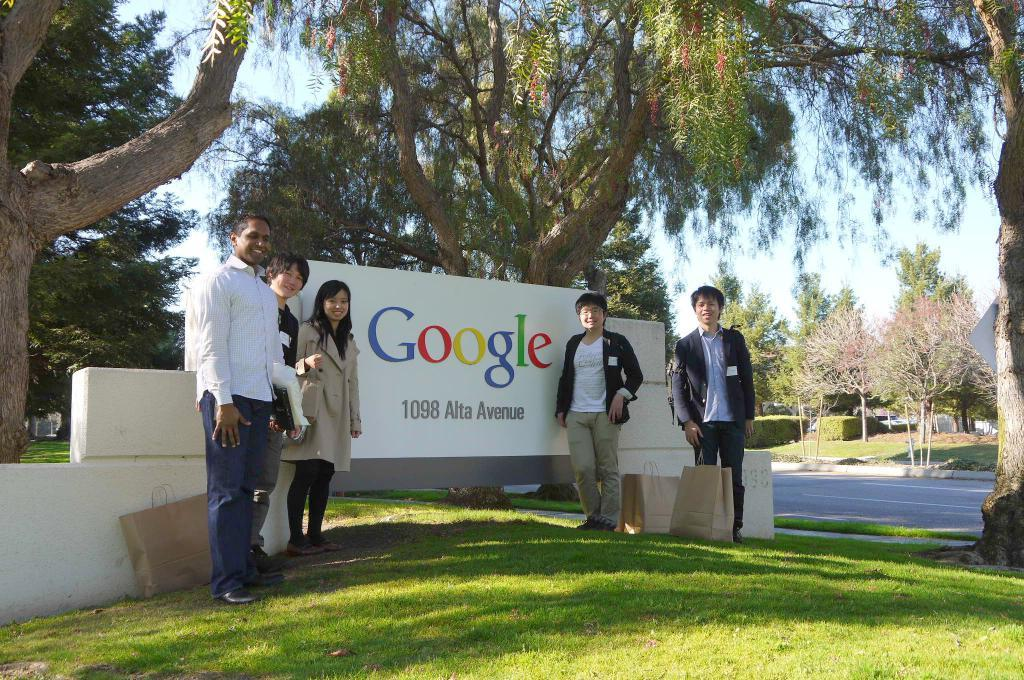How many people are in the image? There is a group of people in the image, but the exact number is not specified. Where are the people standing in the image? The people are standing on the grass in the image. What objects are near the people? There are bags near the people in the image. What can be seen in the background of the image? There are trees and shrubs in the background of the image. What type of rice is being served to the rabbits in the image? There are no rabbits or rice present in the image. How many rats can be seen climbing the trees in the background? There are no rats visible in the image, and the trees are in the background. 